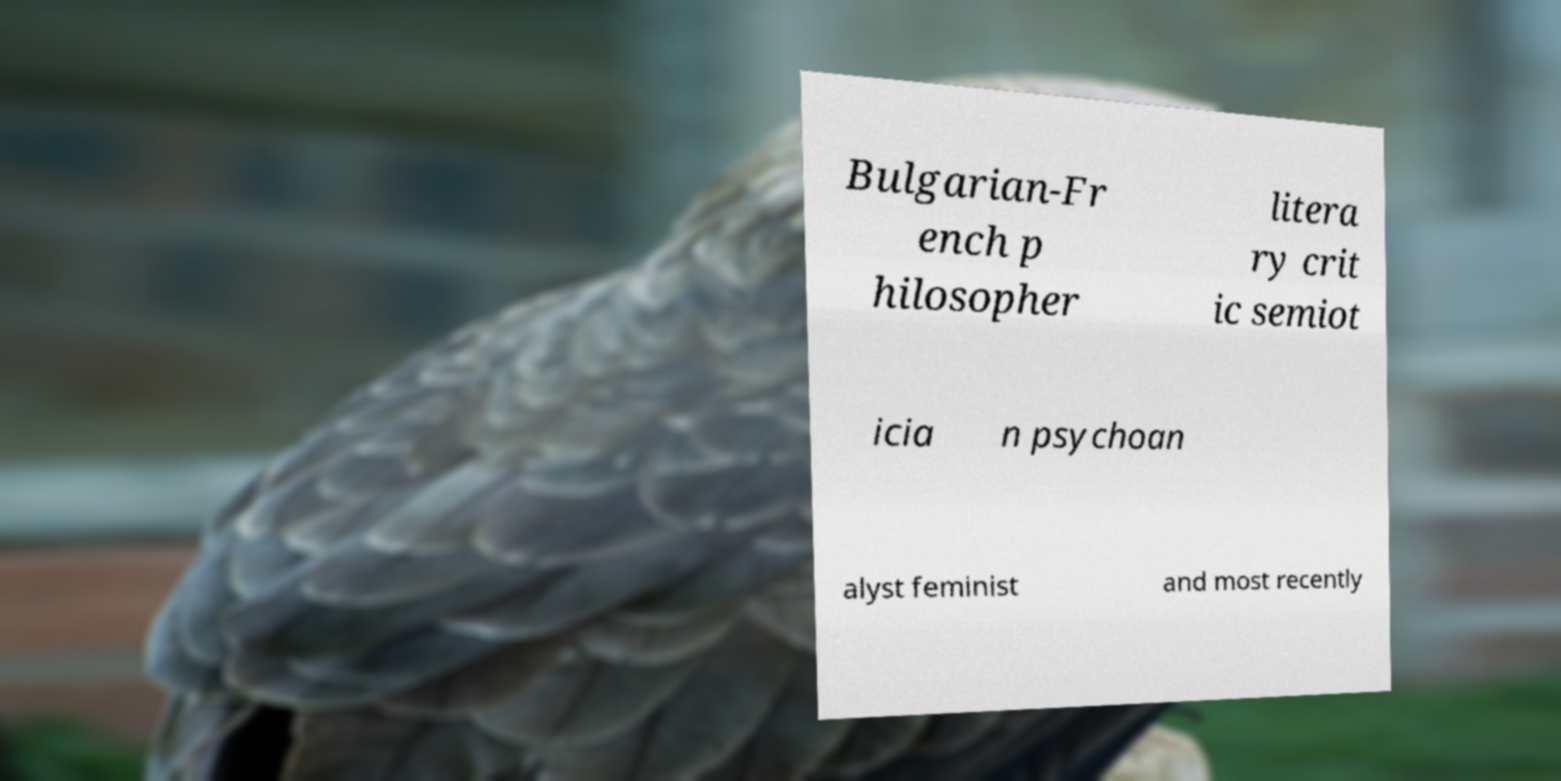What messages or text are displayed in this image? I need them in a readable, typed format. Bulgarian-Fr ench p hilosopher litera ry crit ic semiot icia n psychoan alyst feminist and most recently 